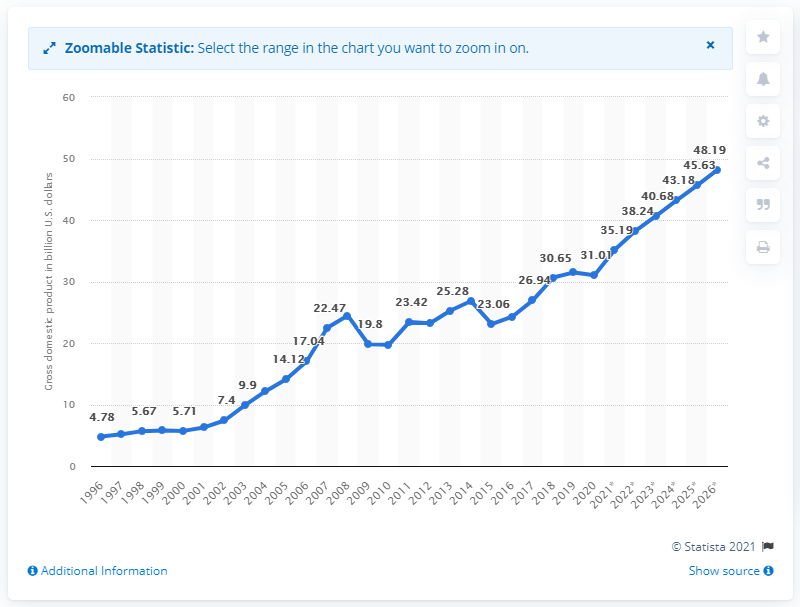Point out several critical features in this image. In 2020, Estonia's gross domestic product was approximately 31.01 dollars. 